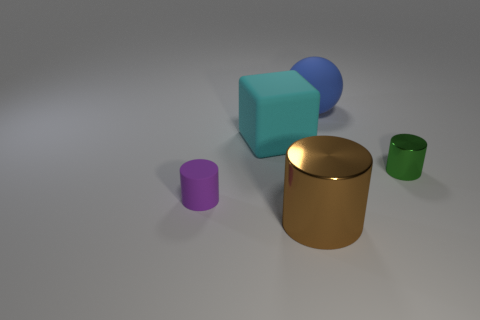Add 4 rubber cylinders. How many objects exist? 9 Subtract all blocks. How many objects are left? 4 Subtract 1 blue balls. How many objects are left? 4 Subtract all big metallic cylinders. Subtract all blue matte objects. How many objects are left? 3 Add 4 cyan things. How many cyan things are left? 5 Add 1 tiny purple cubes. How many tiny purple cubes exist? 1 